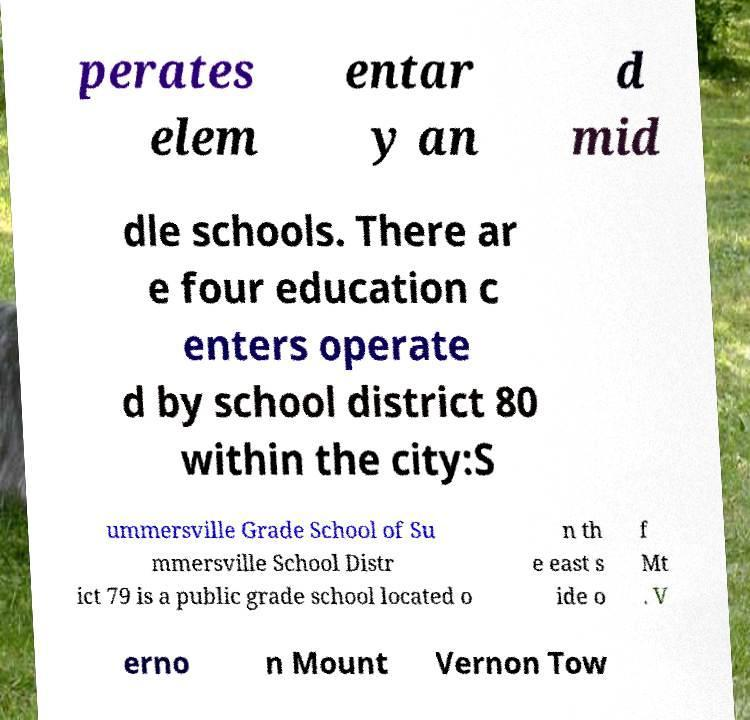There's text embedded in this image that I need extracted. Can you transcribe it verbatim? perates elem entar y an d mid dle schools. There ar e four education c enters operate d by school district 80 within the city:S ummersville Grade School of Su mmersville School Distr ict 79 is a public grade school located o n th e east s ide o f Mt . V erno n Mount Vernon Tow 